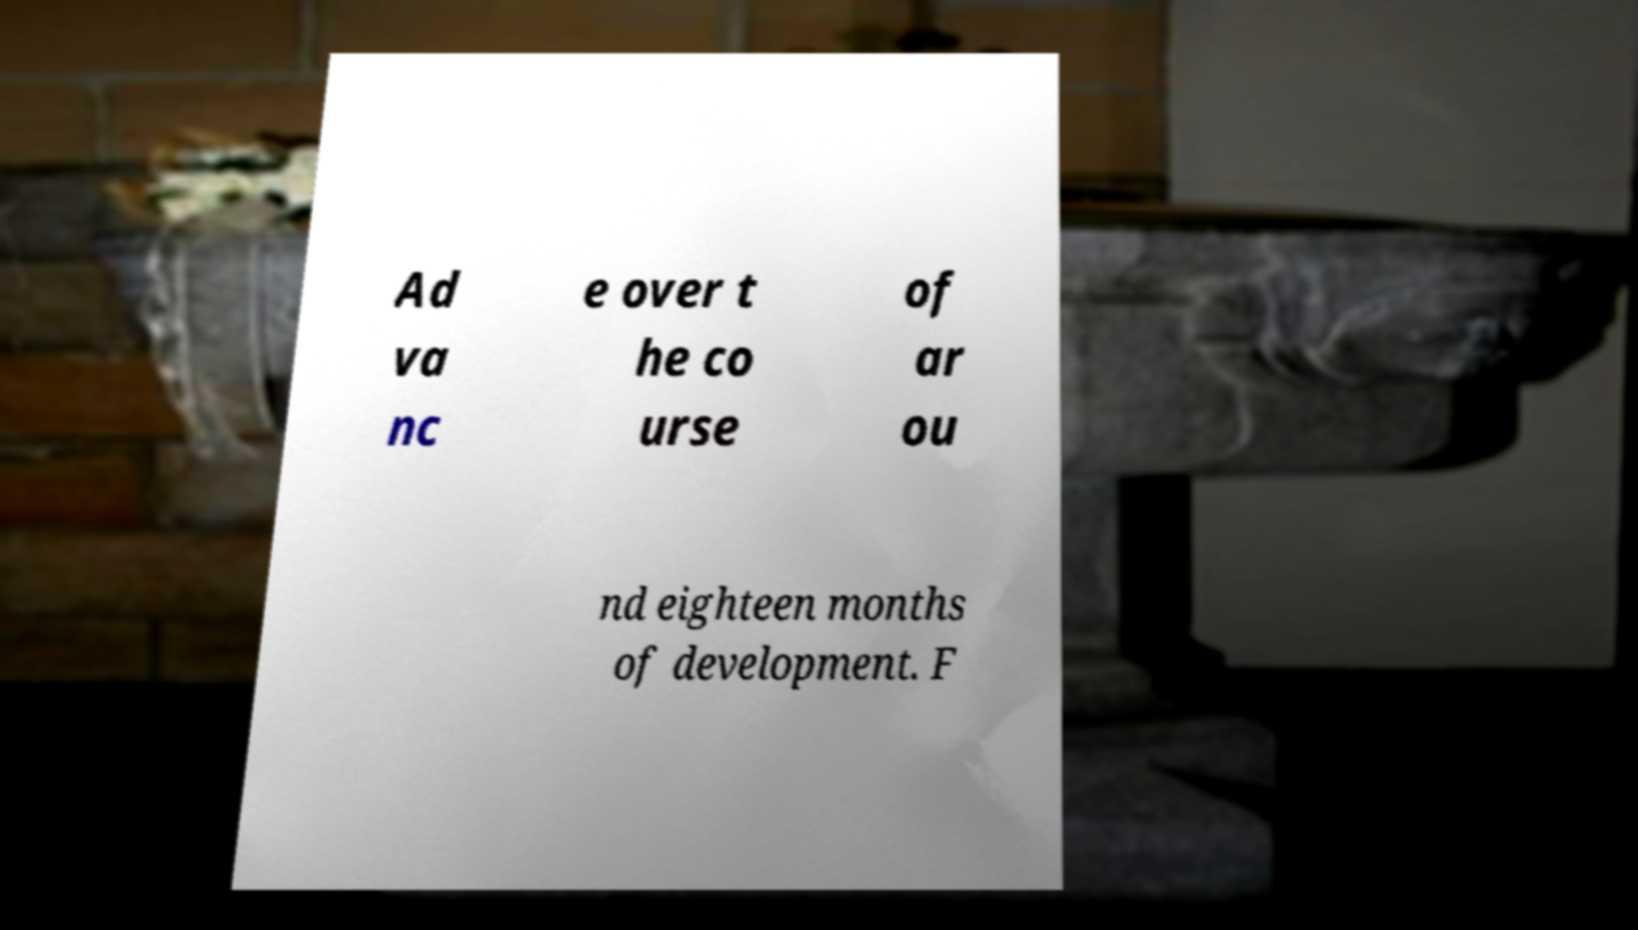Please identify and transcribe the text found in this image. Ad va nc e over t he co urse of ar ou nd eighteen months of development. F 